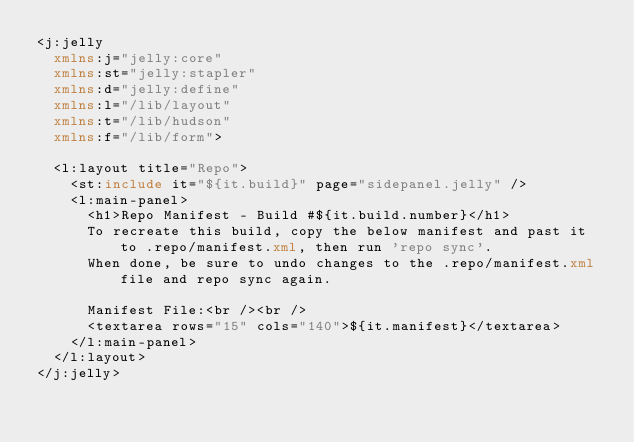<code> <loc_0><loc_0><loc_500><loc_500><_XML_><j:jelly 
	xmlns:j="jelly:core"
	xmlns:st="jelly:stapler"
	xmlns:d="jelly:define"
	xmlns:l="/lib/layout"
	xmlns:t="/lib/hudson"
	xmlns:f="/lib/form">

	<l:layout title="Repo">
		<st:include it="${it.build}" page="sidepanel.jelly" />
		<l:main-panel>
			<h1>Repo Manifest - Build #${it.build.number}</h1>	
			To recreate this build, copy the below manifest and past it to .repo/manifest.xml, then run 'repo sync'.
			When done, be sure to undo changes to the .repo/manifest.xml file and repo sync again.
			
			Manifest File:<br /><br />
			<textarea rows="15" cols="140">${it.manifest}</textarea>
		</l:main-panel>
	</l:layout>
</j:jelly></code> 